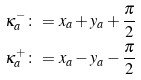Convert formula to latex. <formula><loc_0><loc_0><loc_500><loc_500>\kappa _ { a } ^ { - } & \colon = x _ { a } + y _ { a } + \frac { \pi } { 2 } \\ \kappa _ { a } ^ { + } & \colon = x _ { a } - y _ { a } - \frac { \pi } { 2 }</formula> 